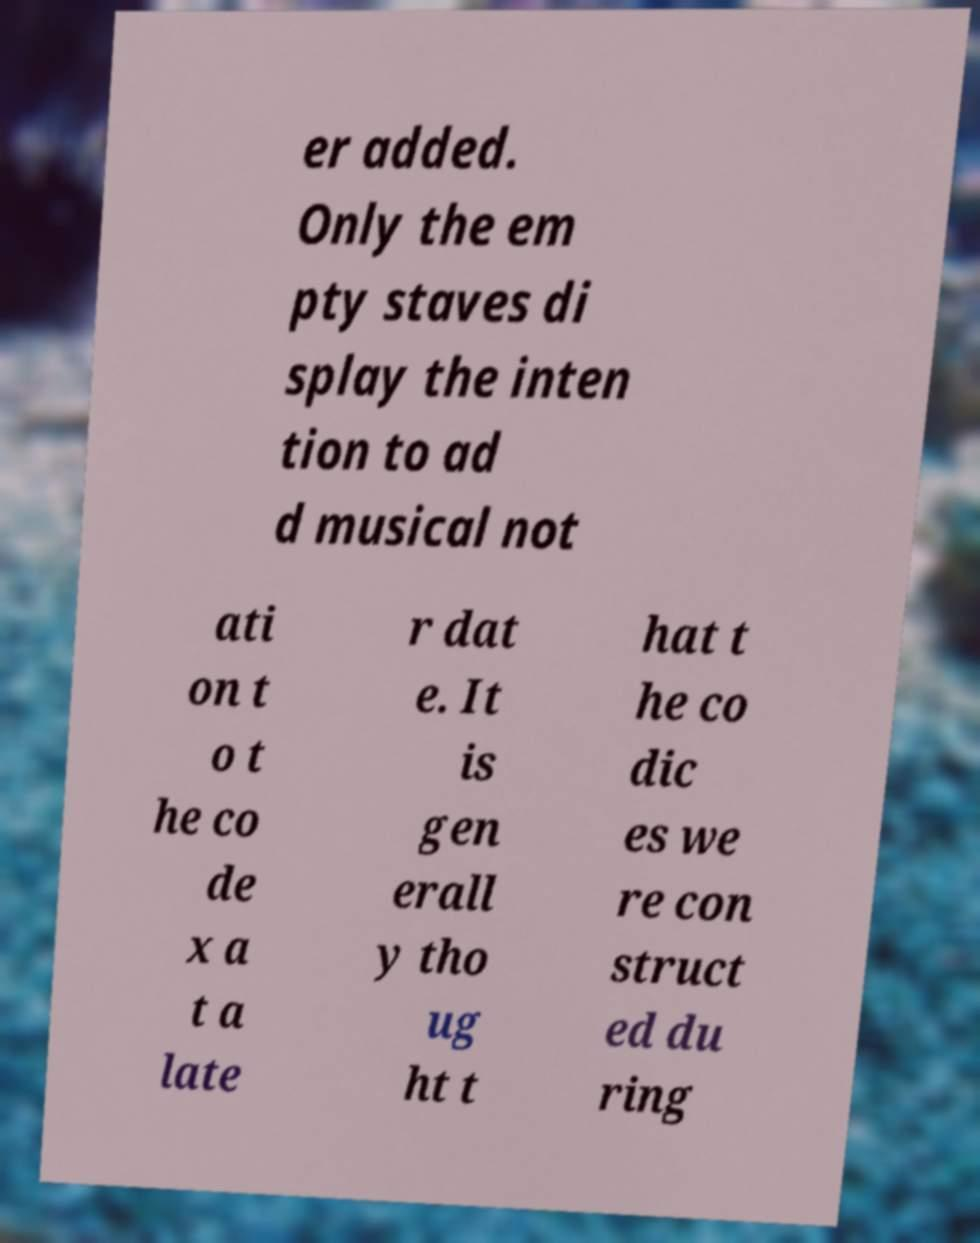Could you extract and type out the text from this image? er added. Only the em pty staves di splay the inten tion to ad d musical not ati on t o t he co de x a t a late r dat e. It is gen erall y tho ug ht t hat t he co dic es we re con struct ed du ring 